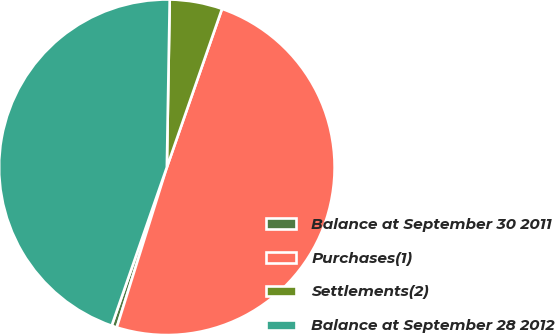<chart> <loc_0><loc_0><loc_500><loc_500><pie_chart><fcel>Balance at September 30 2011<fcel>Purchases(1)<fcel>Settlements(2)<fcel>Balance at September 28 2012<nl><fcel>0.51%<fcel>49.49%<fcel>5.06%<fcel>44.94%<nl></chart> 